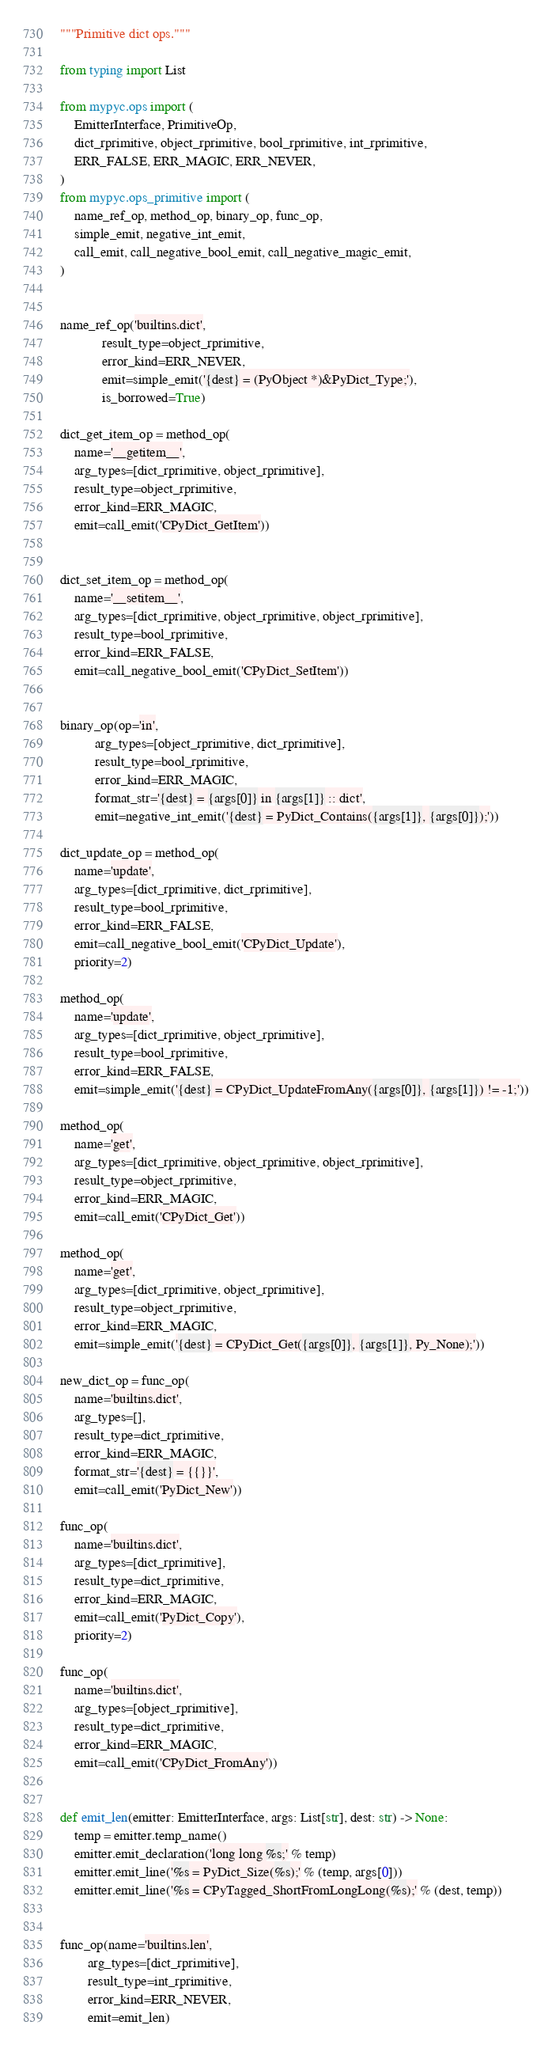<code> <loc_0><loc_0><loc_500><loc_500><_Python_>"""Primitive dict ops."""

from typing import List

from mypyc.ops import (
    EmitterInterface, PrimitiveOp,
    dict_rprimitive, object_rprimitive, bool_rprimitive, int_rprimitive,
    ERR_FALSE, ERR_MAGIC, ERR_NEVER,
)
from mypyc.ops_primitive import (
    name_ref_op, method_op, binary_op, func_op,
    simple_emit, negative_int_emit,
    call_emit, call_negative_bool_emit, call_negative_magic_emit,
)


name_ref_op('builtins.dict',
            result_type=object_rprimitive,
            error_kind=ERR_NEVER,
            emit=simple_emit('{dest} = (PyObject *)&PyDict_Type;'),
            is_borrowed=True)

dict_get_item_op = method_op(
    name='__getitem__',
    arg_types=[dict_rprimitive, object_rprimitive],
    result_type=object_rprimitive,
    error_kind=ERR_MAGIC,
    emit=call_emit('CPyDict_GetItem'))


dict_set_item_op = method_op(
    name='__setitem__',
    arg_types=[dict_rprimitive, object_rprimitive, object_rprimitive],
    result_type=bool_rprimitive,
    error_kind=ERR_FALSE,
    emit=call_negative_bool_emit('CPyDict_SetItem'))


binary_op(op='in',
          arg_types=[object_rprimitive, dict_rprimitive],
          result_type=bool_rprimitive,
          error_kind=ERR_MAGIC,
          format_str='{dest} = {args[0]} in {args[1]} :: dict',
          emit=negative_int_emit('{dest} = PyDict_Contains({args[1]}, {args[0]});'))

dict_update_op = method_op(
    name='update',
    arg_types=[dict_rprimitive, dict_rprimitive],
    result_type=bool_rprimitive,
    error_kind=ERR_FALSE,
    emit=call_negative_bool_emit('CPyDict_Update'),
    priority=2)

method_op(
    name='update',
    arg_types=[dict_rprimitive, object_rprimitive],
    result_type=bool_rprimitive,
    error_kind=ERR_FALSE,
    emit=simple_emit('{dest} = CPyDict_UpdateFromAny({args[0]}, {args[1]}) != -1;'))

method_op(
    name='get',
    arg_types=[dict_rprimitive, object_rprimitive, object_rprimitive],
    result_type=object_rprimitive,
    error_kind=ERR_MAGIC,
    emit=call_emit('CPyDict_Get'))

method_op(
    name='get',
    arg_types=[dict_rprimitive, object_rprimitive],
    result_type=object_rprimitive,
    error_kind=ERR_MAGIC,
    emit=simple_emit('{dest} = CPyDict_Get({args[0]}, {args[1]}, Py_None);'))

new_dict_op = func_op(
    name='builtins.dict',
    arg_types=[],
    result_type=dict_rprimitive,
    error_kind=ERR_MAGIC,
    format_str='{dest} = {{}}',
    emit=call_emit('PyDict_New'))

func_op(
    name='builtins.dict',
    arg_types=[dict_rprimitive],
    result_type=dict_rprimitive,
    error_kind=ERR_MAGIC,
    emit=call_emit('PyDict_Copy'),
    priority=2)

func_op(
    name='builtins.dict',
    arg_types=[object_rprimitive],
    result_type=dict_rprimitive,
    error_kind=ERR_MAGIC,
    emit=call_emit('CPyDict_FromAny'))


def emit_len(emitter: EmitterInterface, args: List[str], dest: str) -> None:
    temp = emitter.temp_name()
    emitter.emit_declaration('long long %s;' % temp)
    emitter.emit_line('%s = PyDict_Size(%s);' % (temp, args[0]))
    emitter.emit_line('%s = CPyTagged_ShortFromLongLong(%s);' % (dest, temp))


func_op(name='builtins.len',
        arg_types=[dict_rprimitive],
        result_type=int_rprimitive,
        error_kind=ERR_NEVER,
        emit=emit_len)
</code> 